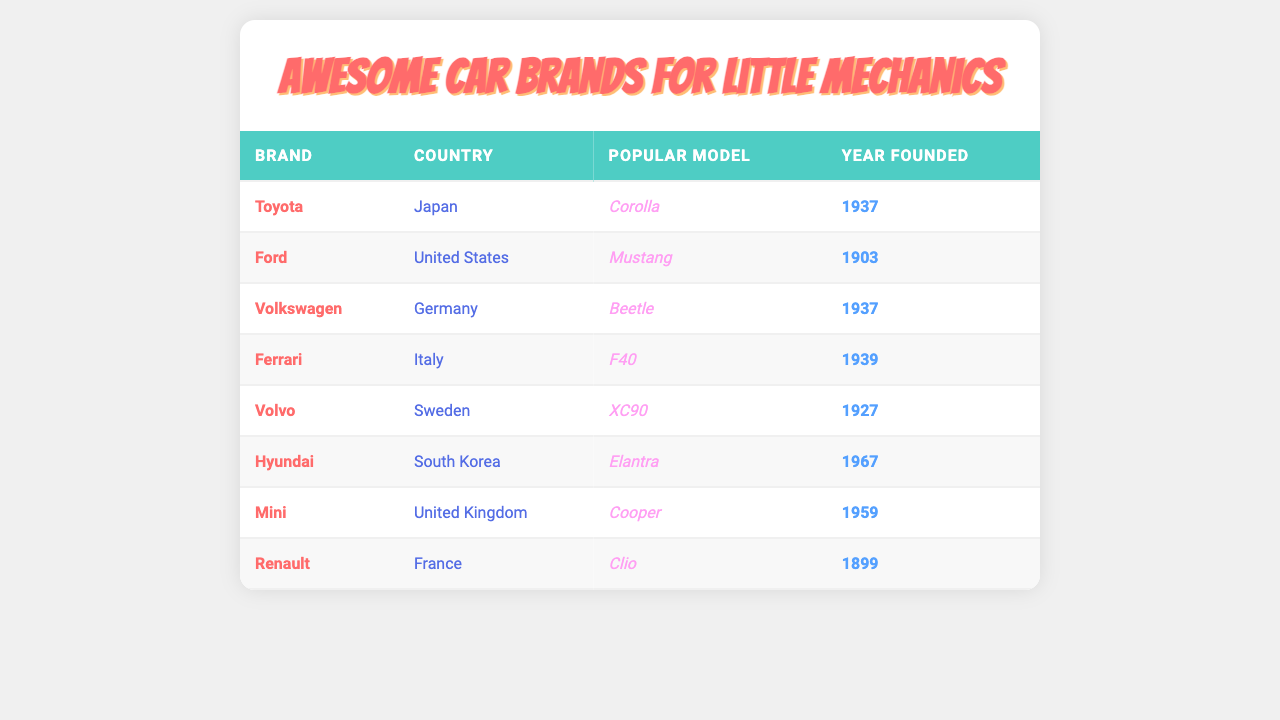What country is Toyota from? Toyota is listed in the table along with its corresponding country of origin, which is Japan.
Answer: Japan Which popular model is associated with Ford? The table shows that the popular model associated with Ford is the Mustang.
Answer: Mustang How many car brands were founded before 1940? By examining the years founded for each brand, we find that Toyota (1937), Volkswagen (1937), and Ferrari (1939) were founded before 1940. This gives us a total of three brands.
Answer: 3 Is Mini from Germany? The table indicates that Mini is from the United Kingdom, not Germany, making this statement false.
Answer: False What is the only car brand from Sweden? According to the table, Volvo is the only car brand listed that has Sweden as its country of origin.
Answer: Volvo Which country has the highest number of car brands in this table? By assessing the countries listed in the table, the United States has two brands (Ford and one more), whereas all others have only one each. Thus, the United States has the highest number.
Answer: United States What is the oldest car brand in the table? Looking at the years founded, Renault (1899) is the oldest car brand in the table, as all other brands were founded later.
Answer: Renault How many years after its founding was Hyundai established compared to Ford? Hyundai was founded in 1967, and Ford was founded in 1903. The difference in their founding years is 1967 - 1903 = 64 years.
Answer: 64 years If we average the founding years of all the car brands, what is the result? To find the average, we add the years founded: 1937 + 1903 + 1937 + 1939 + 1927 + 1967 + 1959 + 1899 = 15389. Dividing by the number of brands (8), the average year is approximately 1923.625, which rounds to 1924.
Answer: 1924 What is the popular model of the German brand? The table shows that the popular model associated with Volkswagen, the German brand, is the Beetle.
Answer: Beetle 